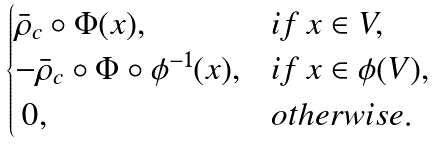Convert formula to latex. <formula><loc_0><loc_0><loc_500><loc_500>\begin{cases} \bar { \rho } _ { c } \circ \Phi ( x ) , & i f \, x \in V , \\ - \bar { \rho } _ { c } \circ \Phi \circ \phi ^ { - 1 } ( x ) , & i f \, x \in \phi ( V ) , \\ \, 0 , & o t h e r w i s e . \end{cases}</formula> 